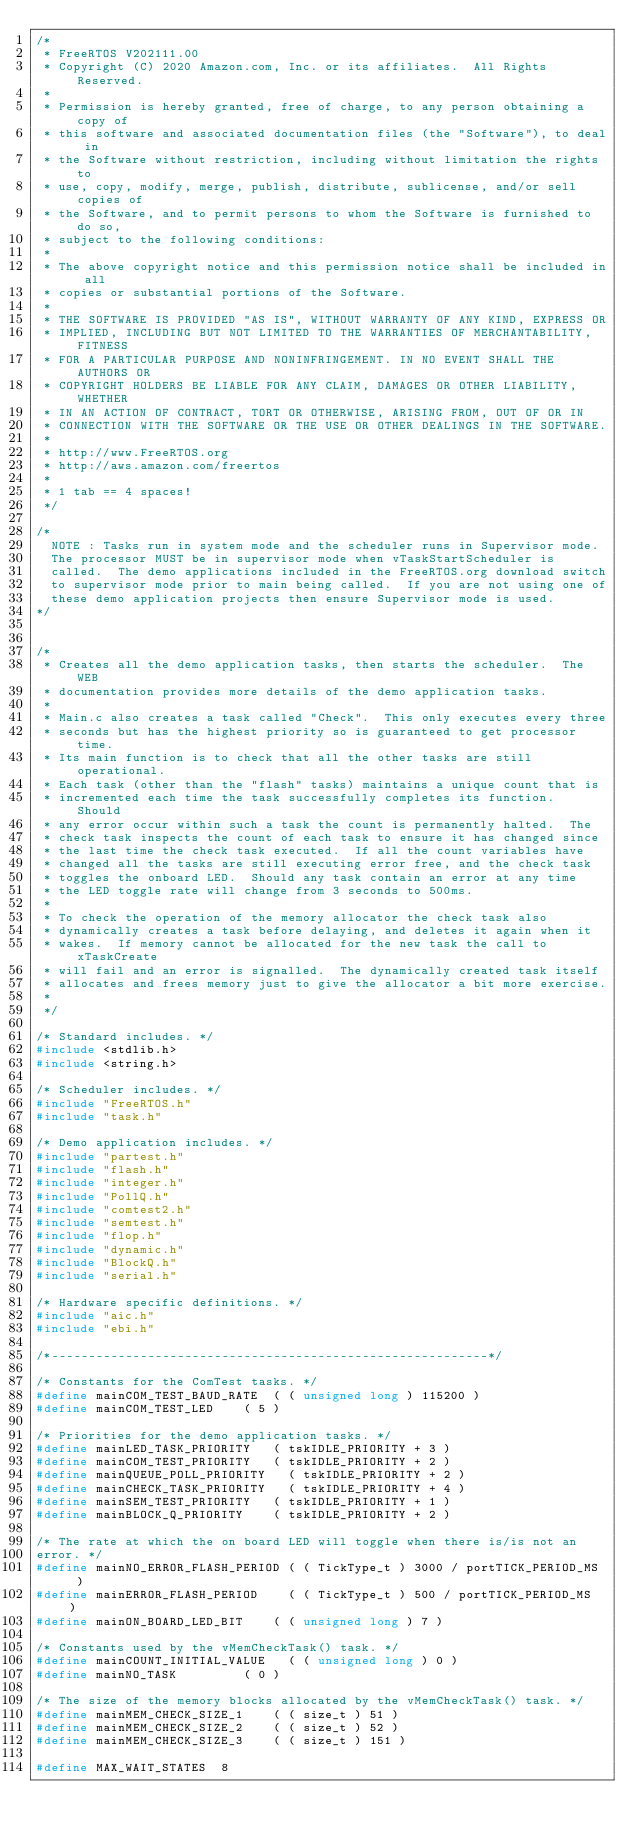<code> <loc_0><loc_0><loc_500><loc_500><_C_>/*
 * FreeRTOS V202111.00
 * Copyright (C) 2020 Amazon.com, Inc. or its affiliates.  All Rights Reserved.
 *
 * Permission is hereby granted, free of charge, to any person obtaining a copy of
 * this software and associated documentation files (the "Software"), to deal in
 * the Software without restriction, including without limitation the rights to
 * use, copy, modify, merge, publish, distribute, sublicense, and/or sell copies of
 * the Software, and to permit persons to whom the Software is furnished to do so,
 * subject to the following conditions:
 *
 * The above copyright notice and this permission notice shall be included in all
 * copies or substantial portions of the Software.
 *
 * THE SOFTWARE IS PROVIDED "AS IS", WITHOUT WARRANTY OF ANY KIND, EXPRESS OR
 * IMPLIED, INCLUDING BUT NOT LIMITED TO THE WARRANTIES OF MERCHANTABILITY, FITNESS
 * FOR A PARTICULAR PURPOSE AND NONINFRINGEMENT. IN NO EVENT SHALL THE AUTHORS OR
 * COPYRIGHT HOLDERS BE LIABLE FOR ANY CLAIM, DAMAGES OR OTHER LIABILITY, WHETHER
 * IN AN ACTION OF CONTRACT, TORT OR OTHERWISE, ARISING FROM, OUT OF OR IN
 * CONNECTION WITH THE SOFTWARE OR THE USE OR OTHER DEALINGS IN THE SOFTWARE.
 *
 * http://www.FreeRTOS.org
 * http://aws.amazon.com/freertos
 *
 * 1 tab == 4 spaces!
 */

/*
	NOTE : Tasks run in system mode and the scheduler runs in Supervisor mode.
	The processor MUST be in supervisor mode when vTaskStartScheduler is
	called.  The demo applications included in the FreeRTOS.org download switch
	to supervisor mode prior to main being called.  If you are not using one of
	these demo application projects then ensure Supervisor mode is used.
*/


/*
 * Creates all the demo application tasks, then starts the scheduler.  The WEB
 * documentation provides more details of the demo application tasks.
 *
 * Main.c also creates a task called "Check".  This only executes every three
 * seconds but has the highest priority so is guaranteed to get processor time.
 * Its main function is to check that all the other tasks are still operational.
 * Each task (other than the "flash" tasks) maintains a unique count that is
 * incremented each time the task successfully completes its function.  Should
 * any error occur within such a task the count is permanently halted.  The
 * check task inspects the count of each task to ensure it has changed since
 * the last time the check task executed.  If all the count variables have
 * changed all the tasks are still executing error free, and the check task
 * toggles the onboard LED.  Should any task contain an error at any time
 * the LED toggle rate will change from 3 seconds to 500ms.
 *
 * To check the operation of the memory allocator the check task also
 * dynamically creates a task before delaying, and deletes it again when it
 * wakes.  If memory cannot be allocated for the new task the call to xTaskCreate
 * will fail and an error is signalled.  The dynamically created task itself
 * allocates and frees memory just to give the allocator a bit more exercise.
 *
 */

/* Standard includes. */
#include <stdlib.h>
#include <string.h>

/* Scheduler includes. */
#include "FreeRTOS.h"
#include "task.h"

/* Demo application includes. */
#include "partest.h"
#include "flash.h"
#include "integer.h"
#include "PollQ.h"
#include "comtest2.h"
#include "semtest.h"
#include "flop.h"
#include "dynamic.h"
#include "BlockQ.h"
#include "serial.h"

/* Hardware specific definitions. */
#include "aic.h"
#include "ebi.h"

/*-----------------------------------------------------------*/

/* Constants for the ComTest tasks. */
#define mainCOM_TEST_BAUD_RATE	( ( unsigned long ) 115200 )
#define mainCOM_TEST_LED		( 5 )

/* Priorities for the demo application tasks. */
#define mainLED_TASK_PRIORITY		( tskIDLE_PRIORITY + 3 )
#define mainCOM_TEST_PRIORITY		( tskIDLE_PRIORITY + 2 )
#define mainQUEUE_POLL_PRIORITY		( tskIDLE_PRIORITY + 2 )
#define mainCHECK_TASK_PRIORITY		( tskIDLE_PRIORITY + 4 )
#define mainSEM_TEST_PRIORITY		( tskIDLE_PRIORITY + 1 )
#define mainBLOCK_Q_PRIORITY		( tskIDLE_PRIORITY + 2 )

/* The rate at which the on board LED will toggle when there is/is not an
error. */
#define mainNO_ERROR_FLASH_PERIOD	( ( TickType_t ) 3000 / portTICK_PERIOD_MS  )
#define mainERROR_FLASH_PERIOD		( ( TickType_t ) 500 / portTICK_PERIOD_MS  )
#define mainON_BOARD_LED_BIT		( ( unsigned long ) 7 )

/* Constants used by the vMemCheckTask() task. */
#define mainCOUNT_INITIAL_VALUE		( ( unsigned long ) 0 )
#define mainNO_TASK					( 0 )

/* The size of the memory blocks allocated by the vMemCheckTask() task. */
#define mainMEM_CHECK_SIZE_1		( ( size_t ) 51 )
#define mainMEM_CHECK_SIZE_2		( ( size_t ) 52 )
#define mainMEM_CHECK_SIZE_3		( ( size_t ) 151 )

#define MAX_WAIT_STATES  8</code> 